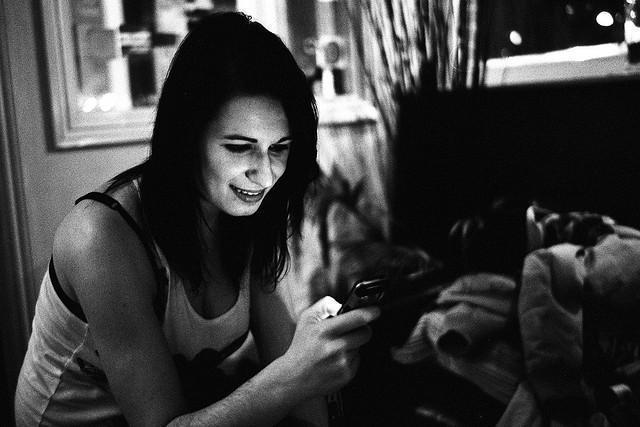How many people are on their phones?
Give a very brief answer. 1. How many yellow bikes are there?
Give a very brief answer. 0. 